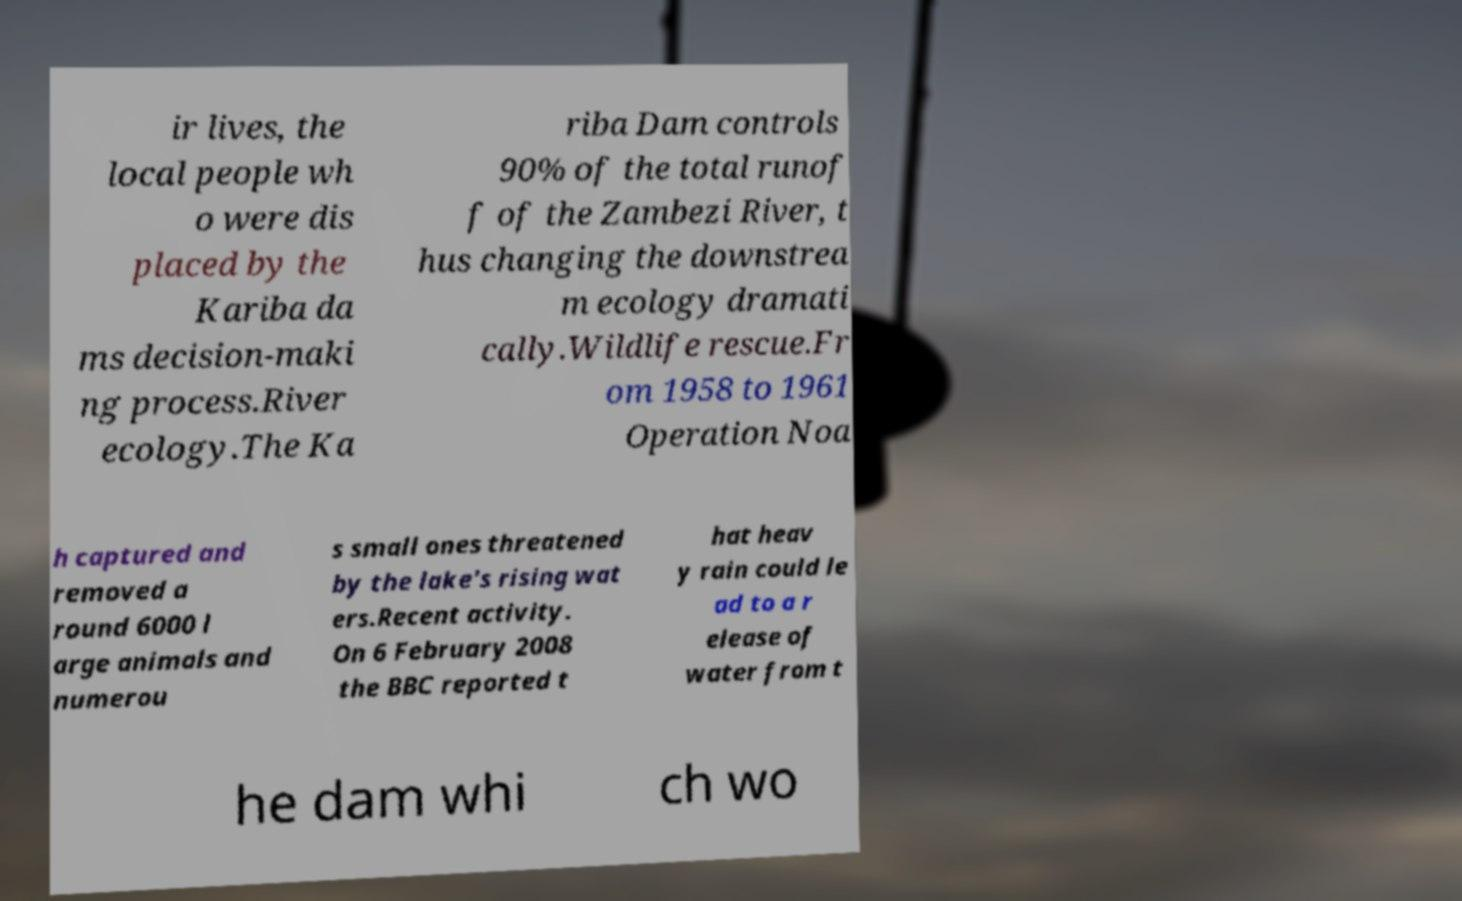Please identify and transcribe the text found in this image. ir lives, the local people wh o were dis placed by the Kariba da ms decision-maki ng process.River ecology.The Ka riba Dam controls 90% of the total runof f of the Zambezi River, t hus changing the downstrea m ecology dramati cally.Wildlife rescue.Fr om 1958 to 1961 Operation Noa h captured and removed a round 6000 l arge animals and numerou s small ones threatened by the lake's rising wat ers.Recent activity. On 6 February 2008 the BBC reported t hat heav y rain could le ad to a r elease of water from t he dam whi ch wo 